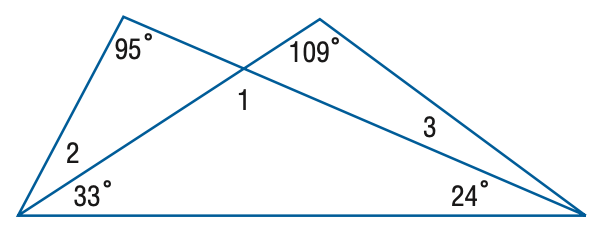Answer the mathemtical geometry problem and directly provide the correct option letter.
Question: Find the measure of \angle 3.
Choices: A: 13 B: 14 C: 15 D: 18 B 